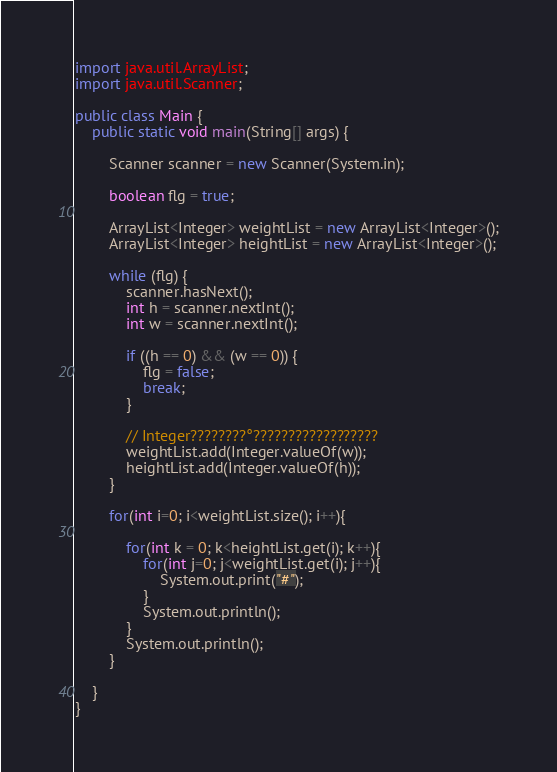Convert code to text. <code><loc_0><loc_0><loc_500><loc_500><_Java_>import java.util.ArrayList;
import java.util.Scanner;

public class Main {
	public static void main(String[] args) {

		Scanner scanner = new Scanner(System.in);

		boolean flg = true;

		ArrayList<Integer> weightList = new ArrayList<Integer>();
		ArrayList<Integer> heightList = new ArrayList<Integer>();

		while (flg) {
			scanner.hasNext();
			int h = scanner.nextInt();
			int w = scanner.nextInt();

			if ((h == 0) && (w == 0)) {
				flg = false;
				break;
			}

			// Integer????????°??????????????????
			weightList.add(Integer.valueOf(w));
			heightList.add(Integer.valueOf(h));
		}

		for(int i=0; i<weightList.size(); i++){

			for(int k = 0; k<heightList.get(i); k++){
				for(int j=0; j<weightList.get(i); j++){
					System.out.print("#");
				}
				System.out.println();
			}
			System.out.println();
		}

	}
}</code> 